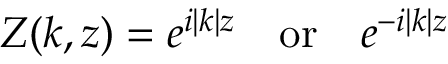Convert formula to latex. <formula><loc_0><loc_0><loc_500><loc_500>Z ( k , z ) = e ^ { i | k | z } \, o r \, e ^ { - i | k | z }</formula> 